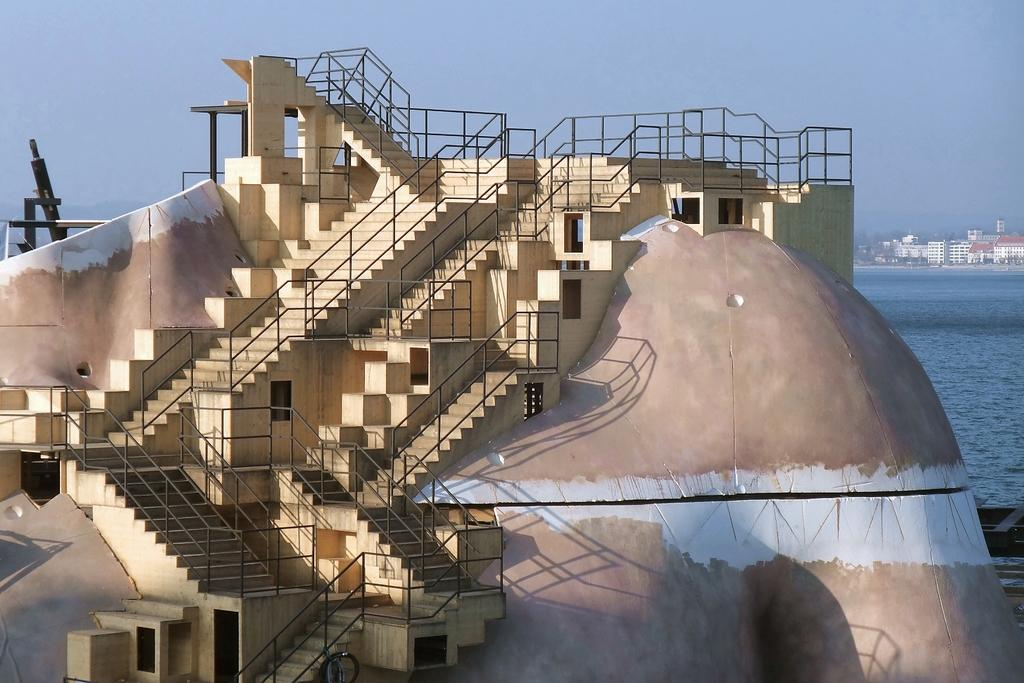What type of structure is present in the image? There is a concrete structure with stairs in the image. What feature does the concrete structure have? The concrete structure has railing. What can be seen in the background of the image? There is a sea, buildings, and the sky visible in the background of the image. What type of ball is the carpenter using to sail in the image? There is no carpenter or ball present in the image, and no sailing activity is depicted. 